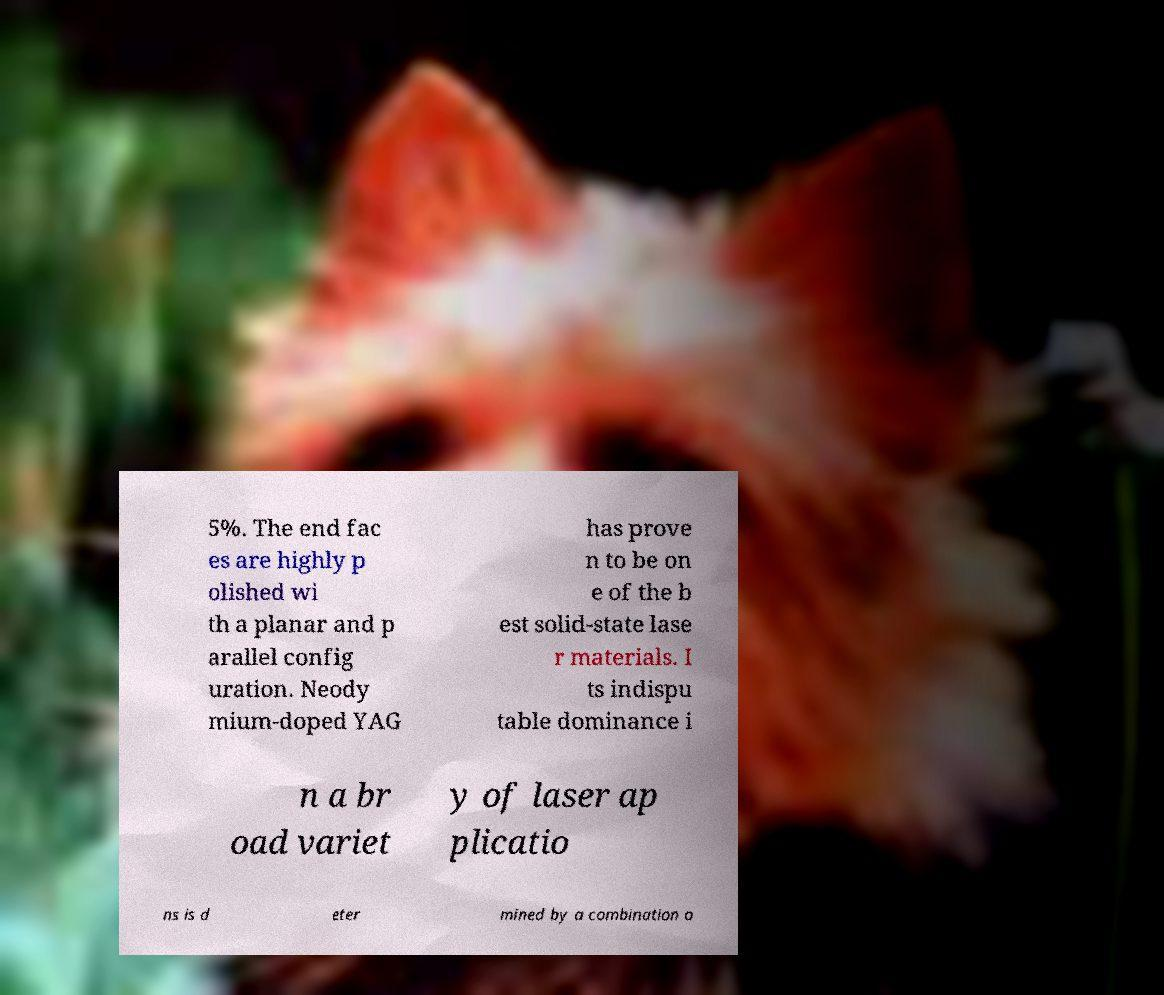For documentation purposes, I need the text within this image transcribed. Could you provide that? 5%. The end fac es are highly p olished wi th a planar and p arallel config uration. Neody mium-doped YAG has prove n to be on e of the b est solid-state lase r materials. I ts indispu table dominance i n a br oad variet y of laser ap plicatio ns is d eter mined by a combination o 